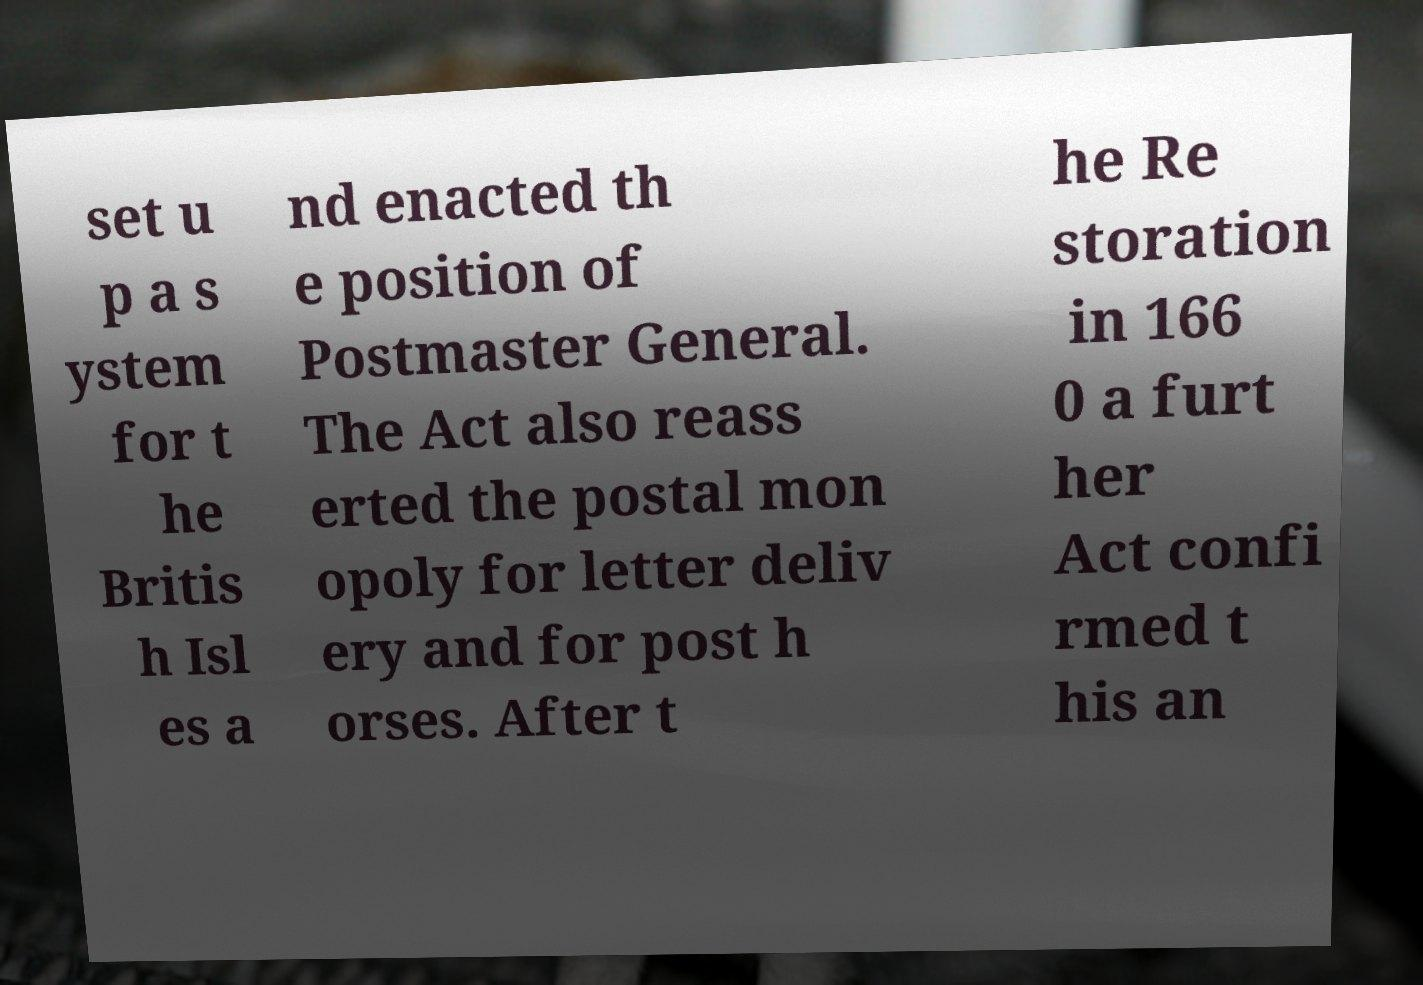Can you read and provide the text displayed in the image?This photo seems to have some interesting text. Can you extract and type it out for me? set u p a s ystem for t he Britis h Isl es a nd enacted th e position of Postmaster General. The Act also reass erted the postal mon opoly for letter deliv ery and for post h orses. After t he Re storation in 166 0 a furt her Act confi rmed t his an 